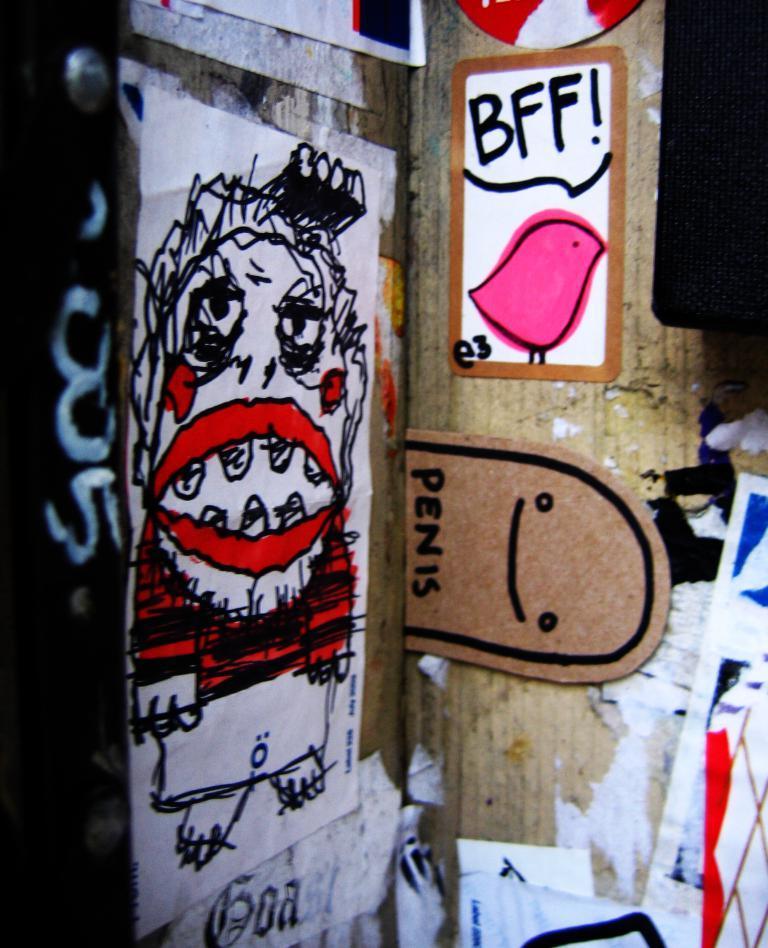In one or two sentences, can you explain what this image depicts? In this image we can see some drawing on the papers and a cardboard sheet which are pasted on a wall. 